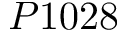<formula> <loc_0><loc_0><loc_500><loc_500>P 1 0 2 8</formula> 